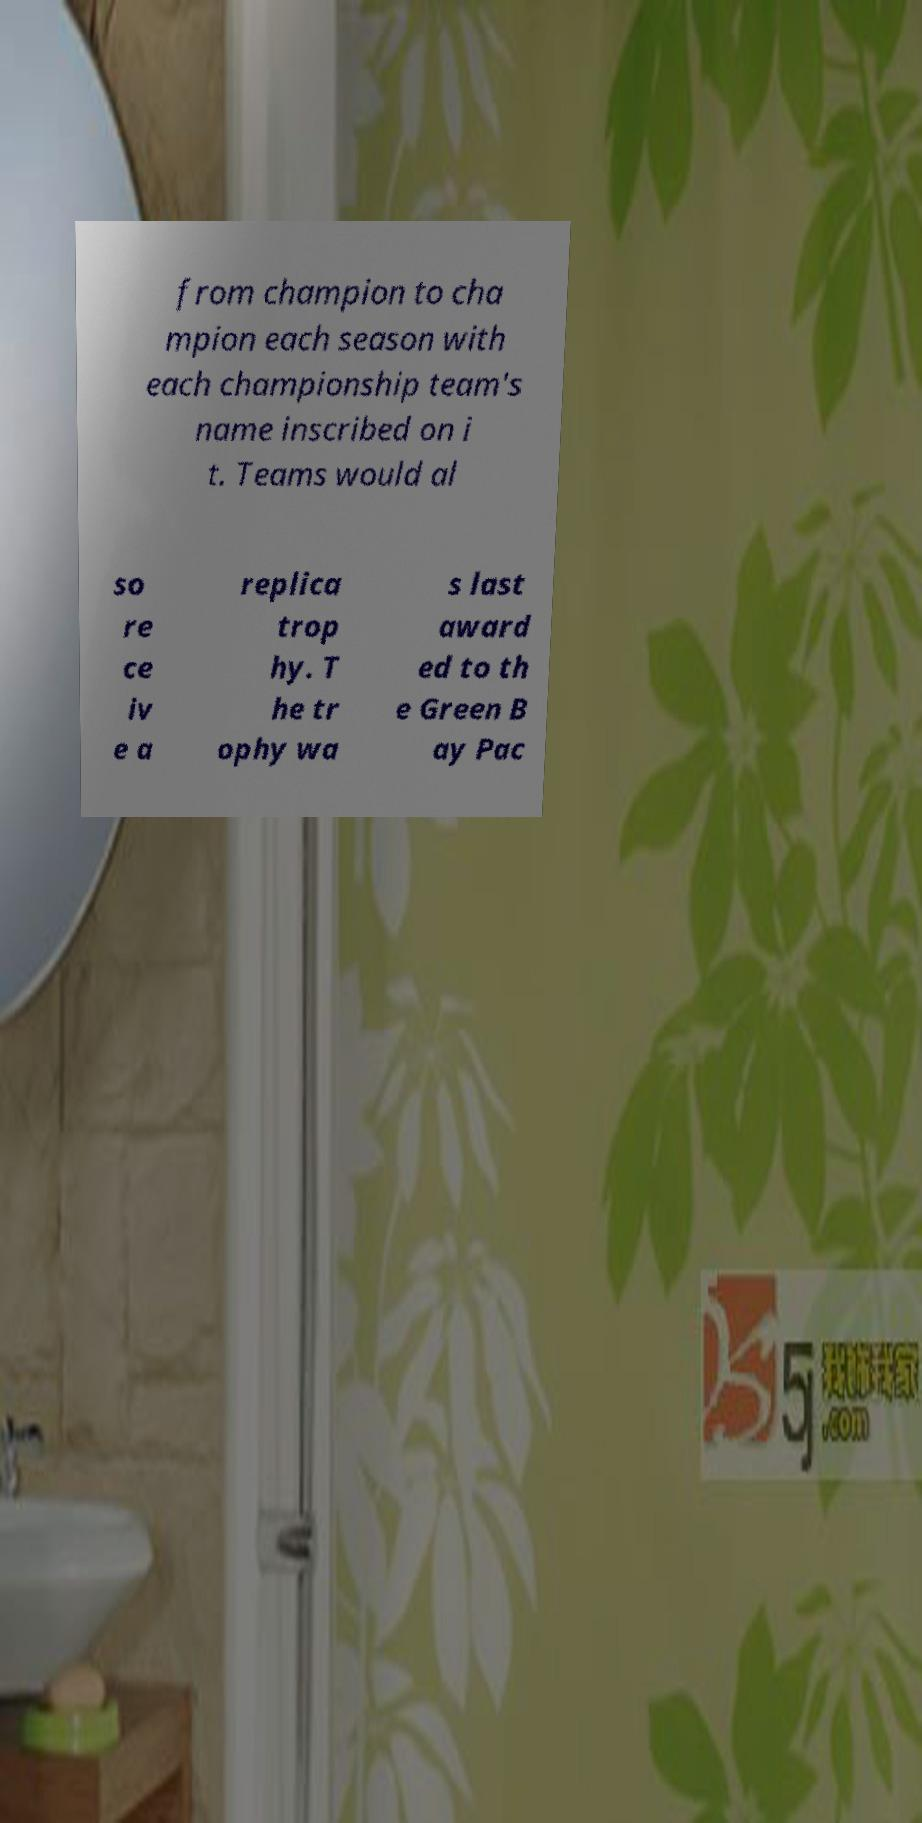What messages or text are displayed in this image? I need them in a readable, typed format. from champion to cha mpion each season with each championship team's name inscribed on i t. Teams would al so re ce iv e a replica trop hy. T he tr ophy wa s last award ed to th e Green B ay Pac 